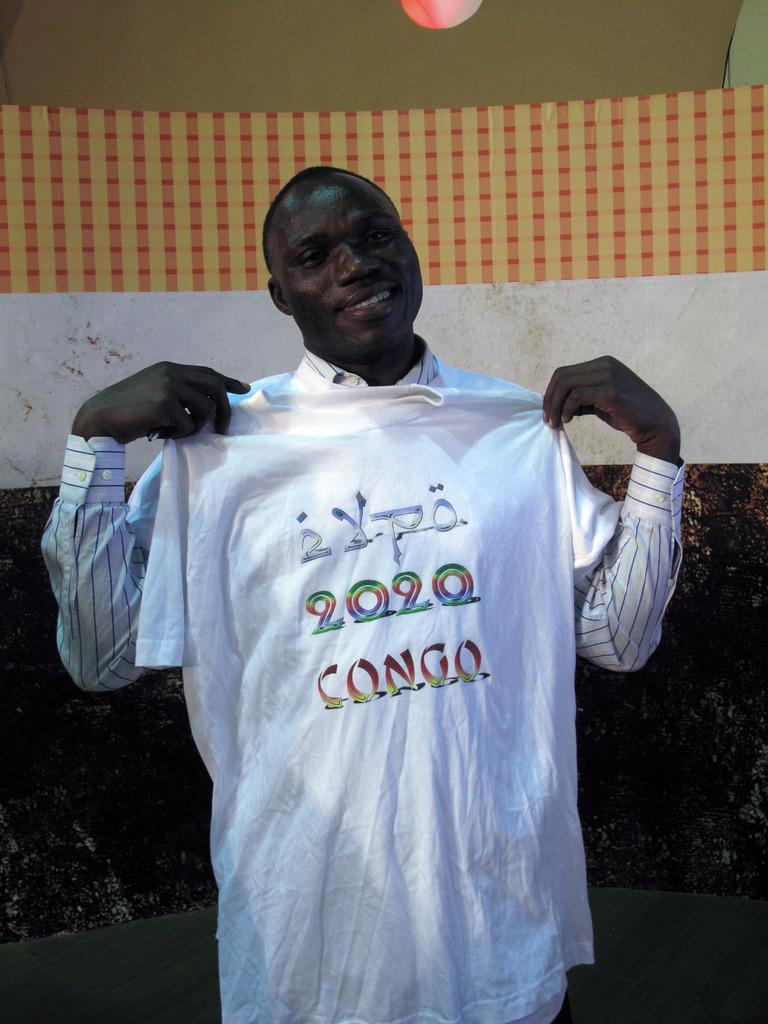<image>
Offer a succinct explanation of the picture presented. a man holding a 2020 shirt in his arms 